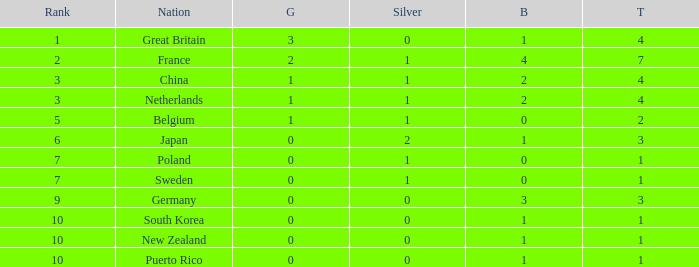What is the smallest number of gold where the total is less than 3 and the silver count is 2? None. 